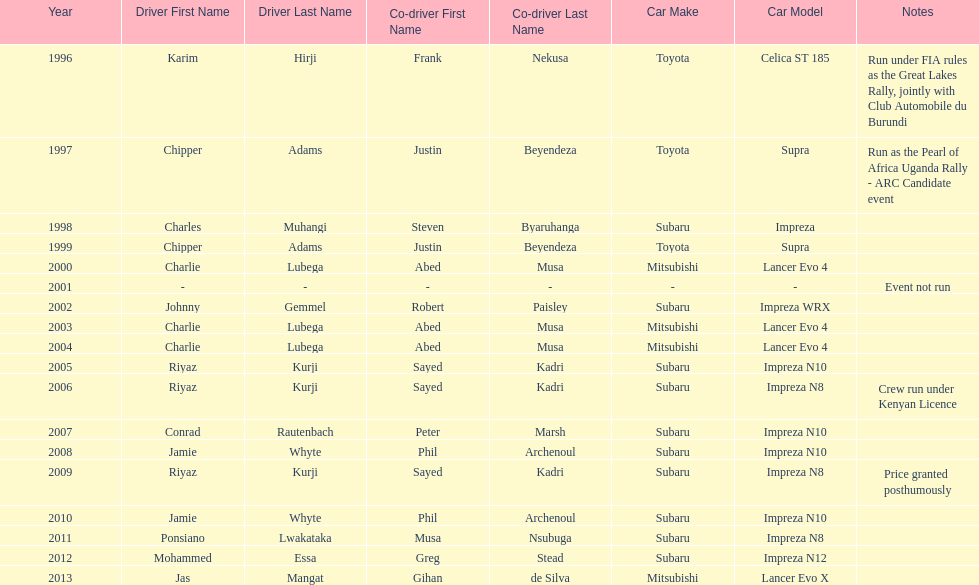How many drivers won at least twice? 4. 